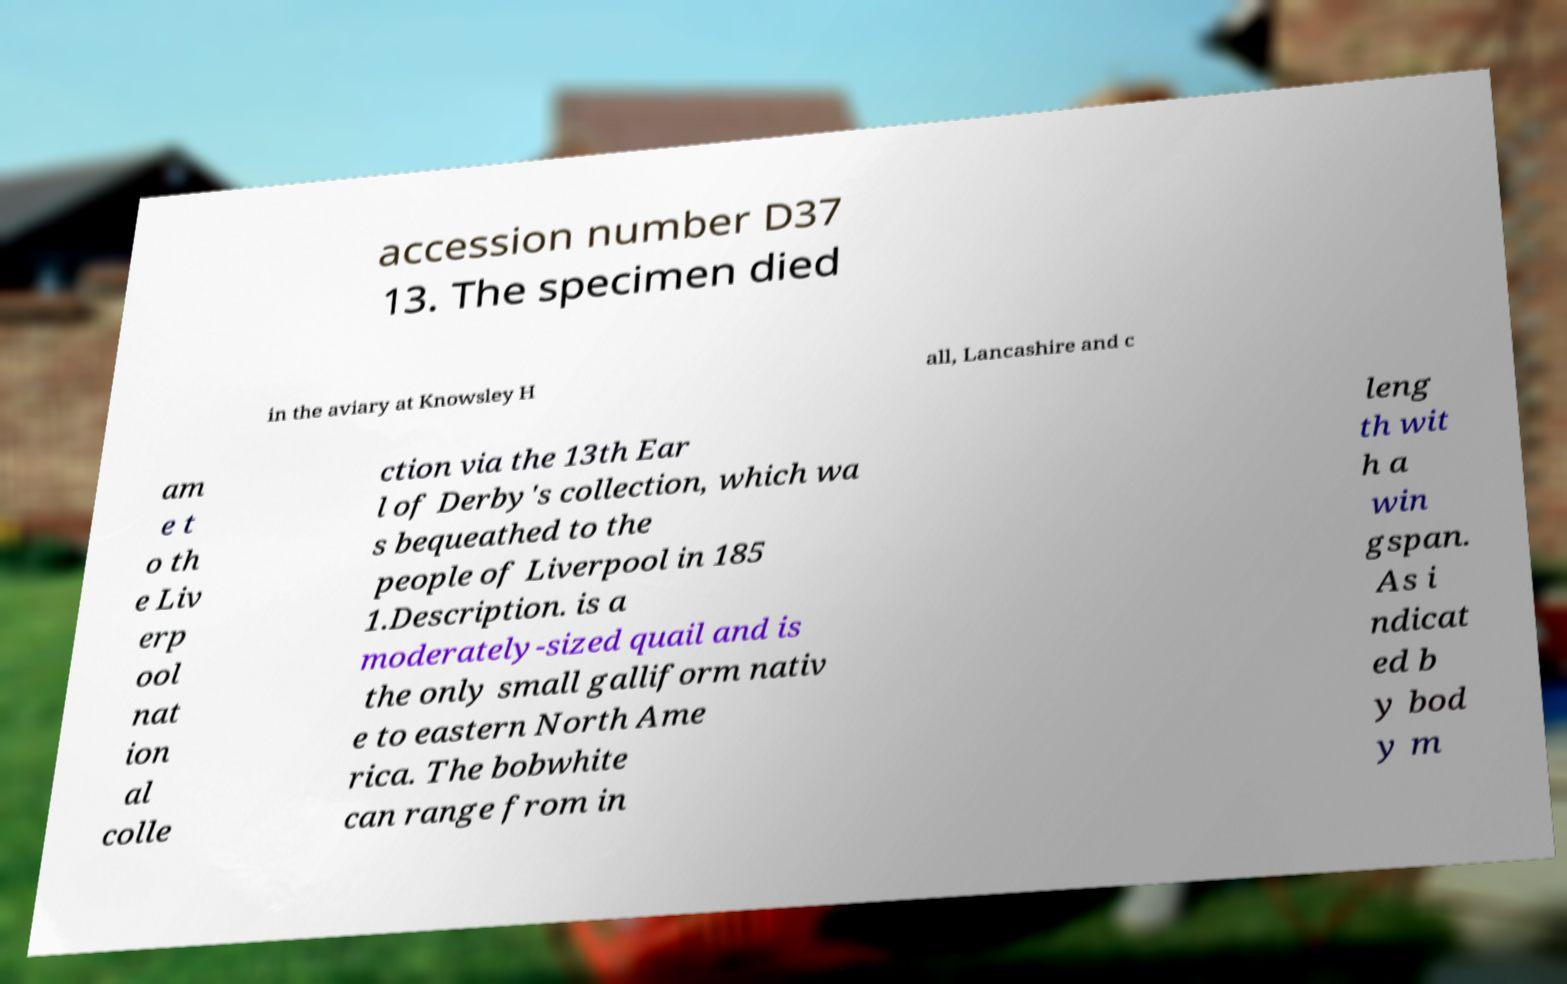For documentation purposes, I need the text within this image transcribed. Could you provide that? accession number D37 13. The specimen died in the aviary at Knowsley H all, Lancashire and c am e t o th e Liv erp ool nat ion al colle ction via the 13th Ear l of Derby's collection, which wa s bequeathed to the people of Liverpool in 185 1.Description. is a moderately-sized quail and is the only small galliform nativ e to eastern North Ame rica. The bobwhite can range from in leng th wit h a win gspan. As i ndicat ed b y bod y m 